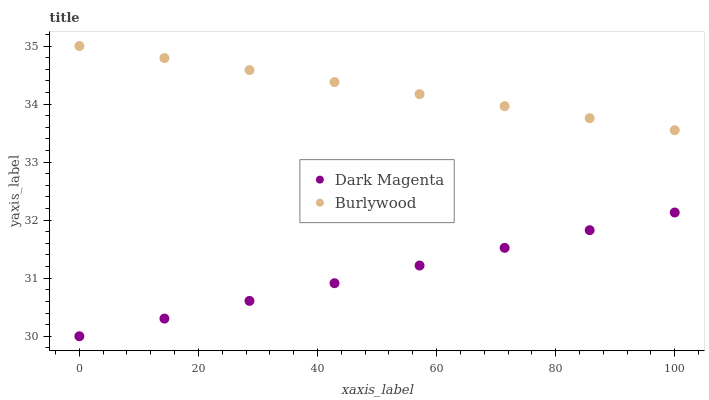Does Dark Magenta have the minimum area under the curve?
Answer yes or no. Yes. Does Burlywood have the maximum area under the curve?
Answer yes or no. Yes. Does Dark Magenta have the maximum area under the curve?
Answer yes or no. No. Is Dark Magenta the smoothest?
Answer yes or no. Yes. Is Burlywood the roughest?
Answer yes or no. Yes. Is Dark Magenta the roughest?
Answer yes or no. No. Does Dark Magenta have the lowest value?
Answer yes or no. Yes. Does Burlywood have the highest value?
Answer yes or no. Yes. Does Dark Magenta have the highest value?
Answer yes or no. No. Is Dark Magenta less than Burlywood?
Answer yes or no. Yes. Is Burlywood greater than Dark Magenta?
Answer yes or no. Yes. Does Dark Magenta intersect Burlywood?
Answer yes or no. No. 